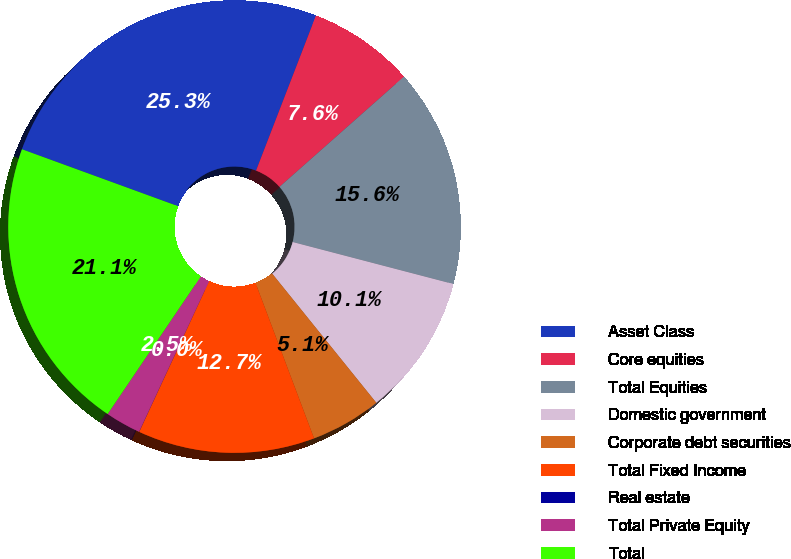Convert chart to OTSL. <chart><loc_0><loc_0><loc_500><loc_500><pie_chart><fcel>Asset Class<fcel>Core equities<fcel>Total Equities<fcel>Domestic government<fcel>Corporate debt securities<fcel>Total Fixed Income<fcel>Real estate<fcel>Total Private Equity<fcel>Total<nl><fcel>25.3%<fcel>7.6%<fcel>15.6%<fcel>10.13%<fcel>5.07%<fcel>12.65%<fcel>0.01%<fcel>2.54%<fcel>21.1%<nl></chart> 